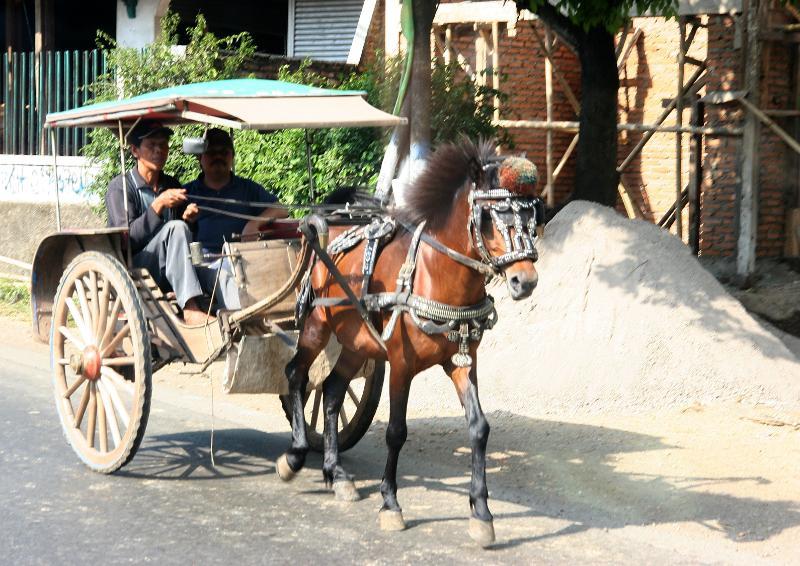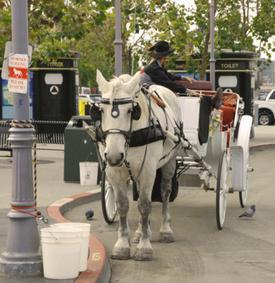The first image is the image on the left, the second image is the image on the right. For the images shown, is this caption "An image shows a four-wheeled wagon pulled by more than one horse." true? Answer yes or no. No. 